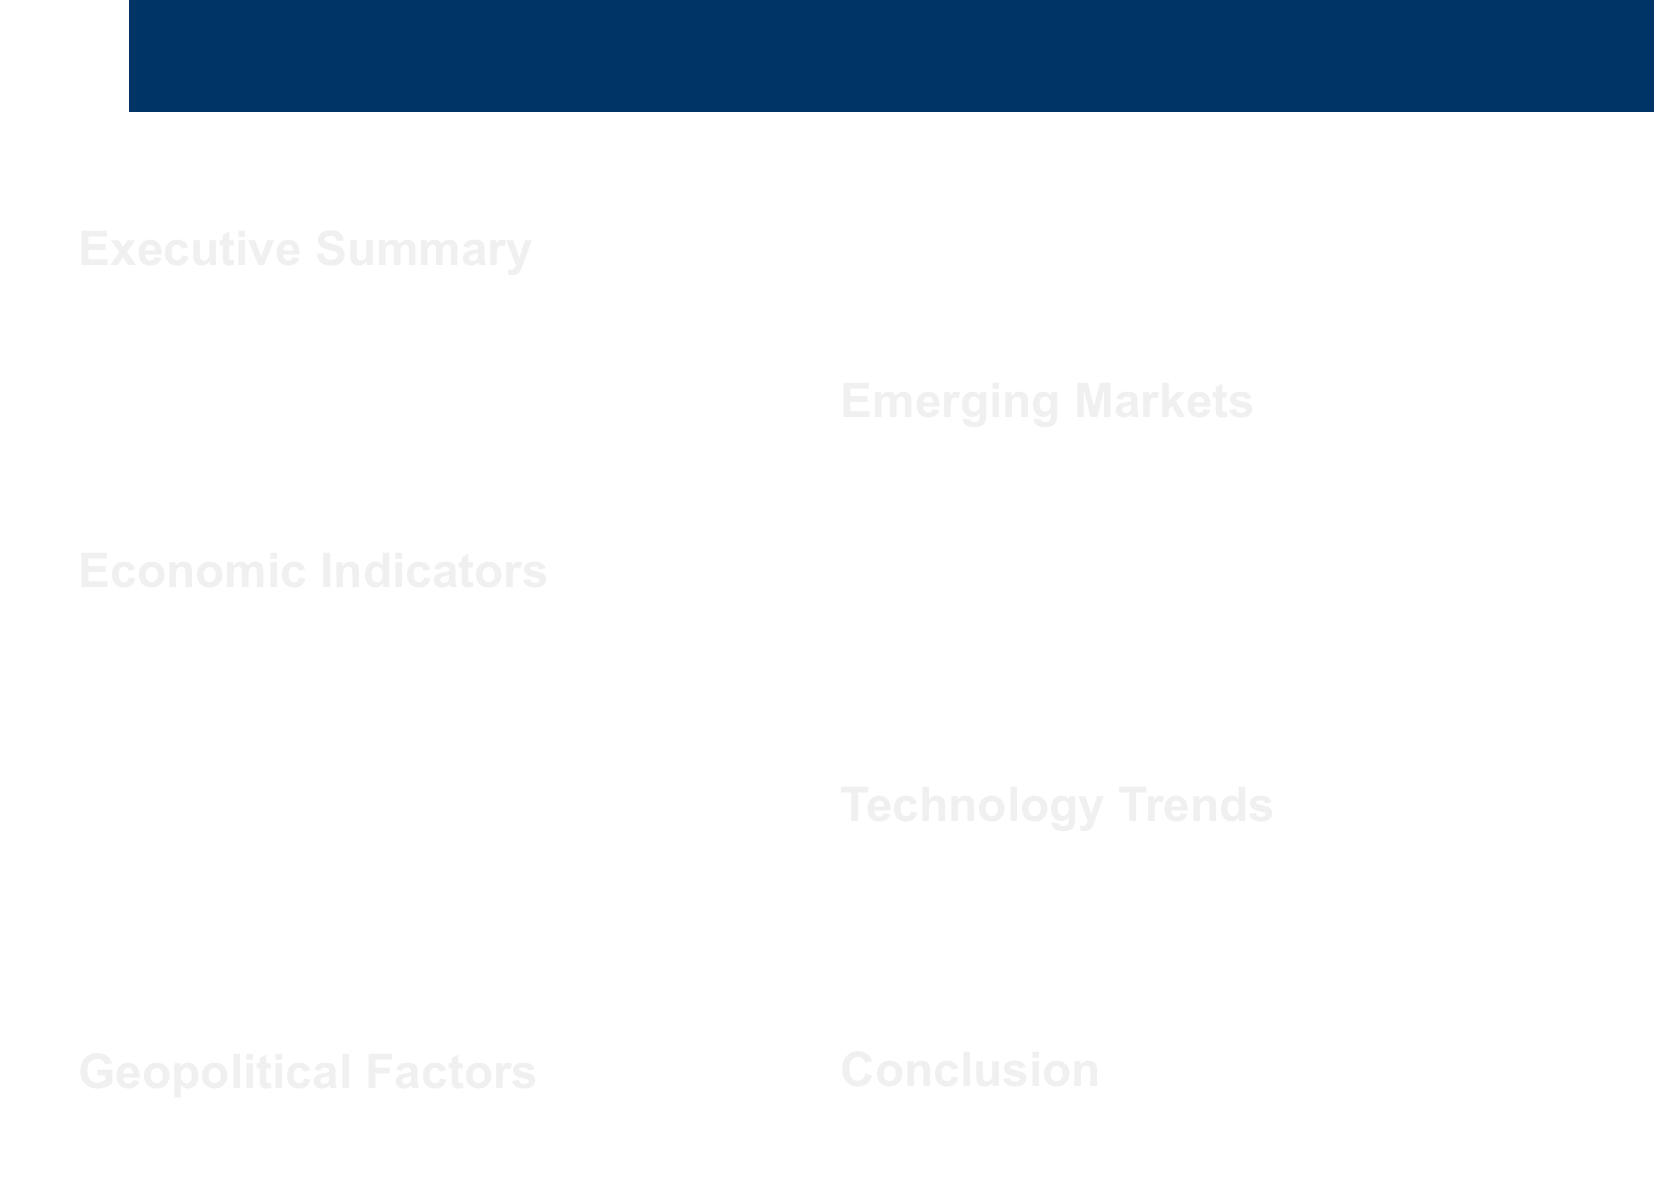What is the projected global GDP growth for 2023? The document states that World Bank projections indicate a global GDP growth of 2.7% in 2023.
Answer: 2.7% What is the forecasted global inflation rate for 2023? According to the IMF, the global inflation rate is forecasted to decrease to 6.6% in 2023.
Answer: 6.6% Which region is mentioned as having ongoing tensions that may affect business travel safety? The document identifies the Middle East as a region with ongoing tensions impacting travel risks.
Answer: Middle East What economic opportunity is presented by India in the report? The report highlights rapid economic growth in India as a business opportunity, while noting infrastructure challenges.
Answer: Rapid economic growth What impact does competition between China and ASEAN countries have according to the document? The document mentions that rising competition may affect regional stability and business travel safety in Southeast Asia.
Answer: Regional stability What technology is enhancing traveler safety? The document states that advancements in AI and data analytics are improving risk assessment and monitoring capabilities.
Answer: AI and data analytics What is the conclusion regarding the relationship between economic trends and business travel safety? The report concludes that the interplay of trends and regional factors significantly impacts business travel safety.
Answer: Interplay of global economic trends What opportunity does Brazil offer for business, according to the report? Brazil's economic recovery is attracting investors, but there are concerns about political instability for business travelers.
Answer: Economic recovery What is recommended for ensuring traveler security in the evolving global landscape? Continuous monitoring and adaptive strategies are recommended for ensuring traveler security, as noted in the conclusion.
Answer: Continuous monitoring and adaptive strategies 